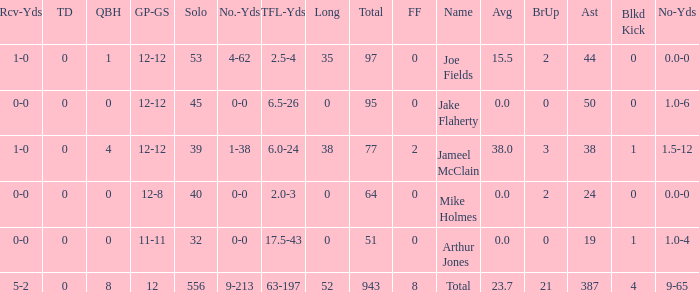How many players named jake flaherty? 1.0. 